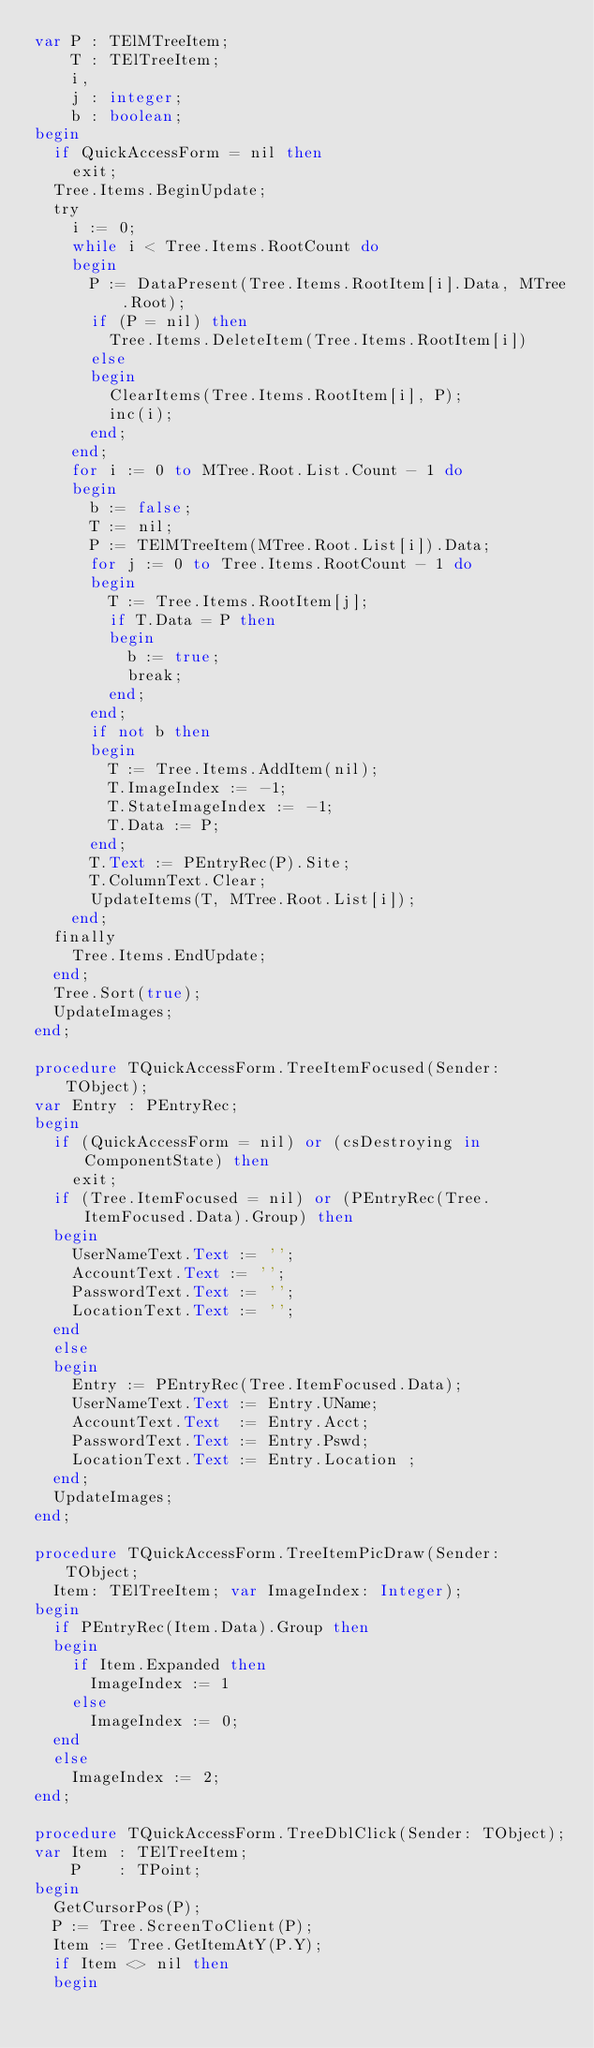<code> <loc_0><loc_0><loc_500><loc_500><_Pascal_>var P : TElMTreeItem;
    T : TElTreeItem;
    i,
    j : integer;
    b : boolean;
begin
  if QuickAccessForm = nil then
    exit;
  Tree.Items.BeginUpdate;
  try
    i := 0;
    while i < Tree.Items.RootCount do
    begin
      P := DataPresent(Tree.Items.RootItem[i].Data, MTree.Root);
      if (P = nil) then
        Tree.Items.DeleteItem(Tree.Items.RootItem[i])
      else
      begin
        ClearItems(Tree.Items.RootItem[i], P);
        inc(i);
      end;
    end;
    for i := 0 to MTree.Root.List.Count - 1 do
    begin
      b := false;
      T := nil;
      P := TElMTreeItem(MTree.Root.List[i]).Data;
      for j := 0 to Tree.Items.RootCount - 1 do
      begin
        T := Tree.Items.RootItem[j];
        if T.Data = P then
        begin
          b := true;
          break;
        end;
      end;
      if not b then
      begin
        T := Tree.Items.AddItem(nil);
        T.ImageIndex := -1;
        T.StateImageIndex := -1;
        T.Data := P;
      end;
      T.Text := PEntryRec(P).Site;
      T.ColumnText.Clear;
      UpdateItems(T, MTree.Root.List[i]);
    end;
  finally
    Tree.Items.EndUpdate;
  end;
  Tree.Sort(true);
  UpdateImages;
end;

procedure TQuickAccessForm.TreeItemFocused(Sender: TObject);
var Entry : PEntryRec;
begin
  if (QuickAccessForm = nil) or (csDestroying in ComponentState) then
    exit;
  if (Tree.ItemFocused = nil) or (PEntryRec(Tree.ItemFocused.Data).Group) then
  begin
    UserNameText.Text := '';
    AccountText.Text := '';
    PasswordText.Text := '';
    LocationText.Text := '';
  end
  else
  begin
    Entry := PEntryRec(Tree.ItemFocused.Data);
    UserNameText.Text := Entry.UName;
    AccountText.Text  := Entry.Acct;
    PasswordText.Text := Entry.Pswd;
    LocationText.Text := Entry.Location ;
  end;
  UpdateImages;
end;

procedure TQuickAccessForm.TreeItemPicDraw(Sender: TObject;
  Item: TElTreeItem; var ImageIndex: Integer);
begin
  if PEntryRec(Item.Data).Group then
  begin
    if Item.Expanded then
      ImageIndex := 1
    else
      ImageIndex := 0;
  end
  else
    ImageIndex := 2;
end;

procedure TQuickAccessForm.TreeDblClick(Sender: TObject);
var Item : TElTreeItem;
    P    : TPoint;
begin
  GetCursorPos(P);
  P := Tree.ScreenToClient(P);
  Item := Tree.GetItemAtY(P.Y);
  if Item <> nil then
  begin</code> 